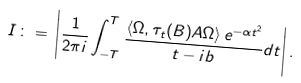Convert formula to latex. <formula><loc_0><loc_0><loc_500><loc_500>I \, \colon = \, \left | \frac { 1 } { 2 \pi i } \int _ { - T } ^ { T } \frac { \langle \Omega , \tau _ { t } ( B ) A \Omega \rangle \, e ^ { - \alpha t ^ { 2 } } } { t - i b } d t \right | .</formula> 